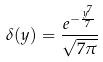<formula> <loc_0><loc_0><loc_500><loc_500>\delta ( y ) = \frac { e ^ { - \frac { y ^ { 7 } } { 7 } } } { \sqrt { 7 \pi } }</formula> 